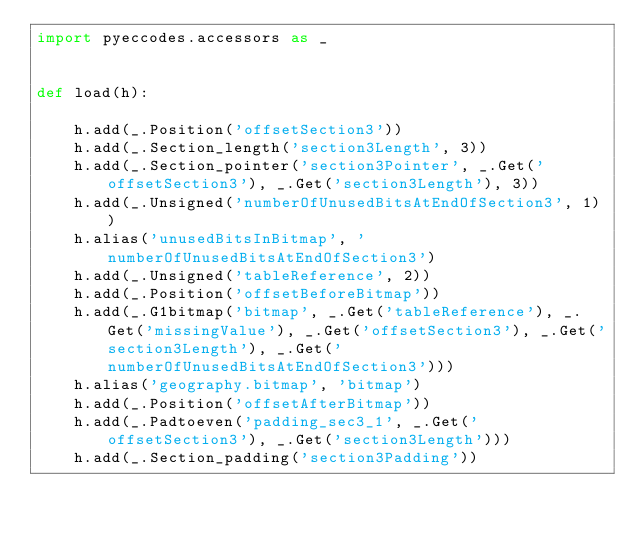Convert code to text. <code><loc_0><loc_0><loc_500><loc_500><_Python_>import pyeccodes.accessors as _


def load(h):

    h.add(_.Position('offsetSection3'))
    h.add(_.Section_length('section3Length', 3))
    h.add(_.Section_pointer('section3Pointer', _.Get('offsetSection3'), _.Get('section3Length'), 3))
    h.add(_.Unsigned('numberOfUnusedBitsAtEndOfSection3', 1))
    h.alias('unusedBitsInBitmap', 'numberOfUnusedBitsAtEndOfSection3')
    h.add(_.Unsigned('tableReference', 2))
    h.add(_.Position('offsetBeforeBitmap'))
    h.add(_.G1bitmap('bitmap', _.Get('tableReference'), _.Get('missingValue'), _.Get('offsetSection3'), _.Get('section3Length'), _.Get('numberOfUnusedBitsAtEndOfSection3')))
    h.alias('geography.bitmap', 'bitmap')
    h.add(_.Position('offsetAfterBitmap'))
    h.add(_.Padtoeven('padding_sec3_1', _.Get('offsetSection3'), _.Get('section3Length')))
    h.add(_.Section_padding('section3Padding'))</code> 